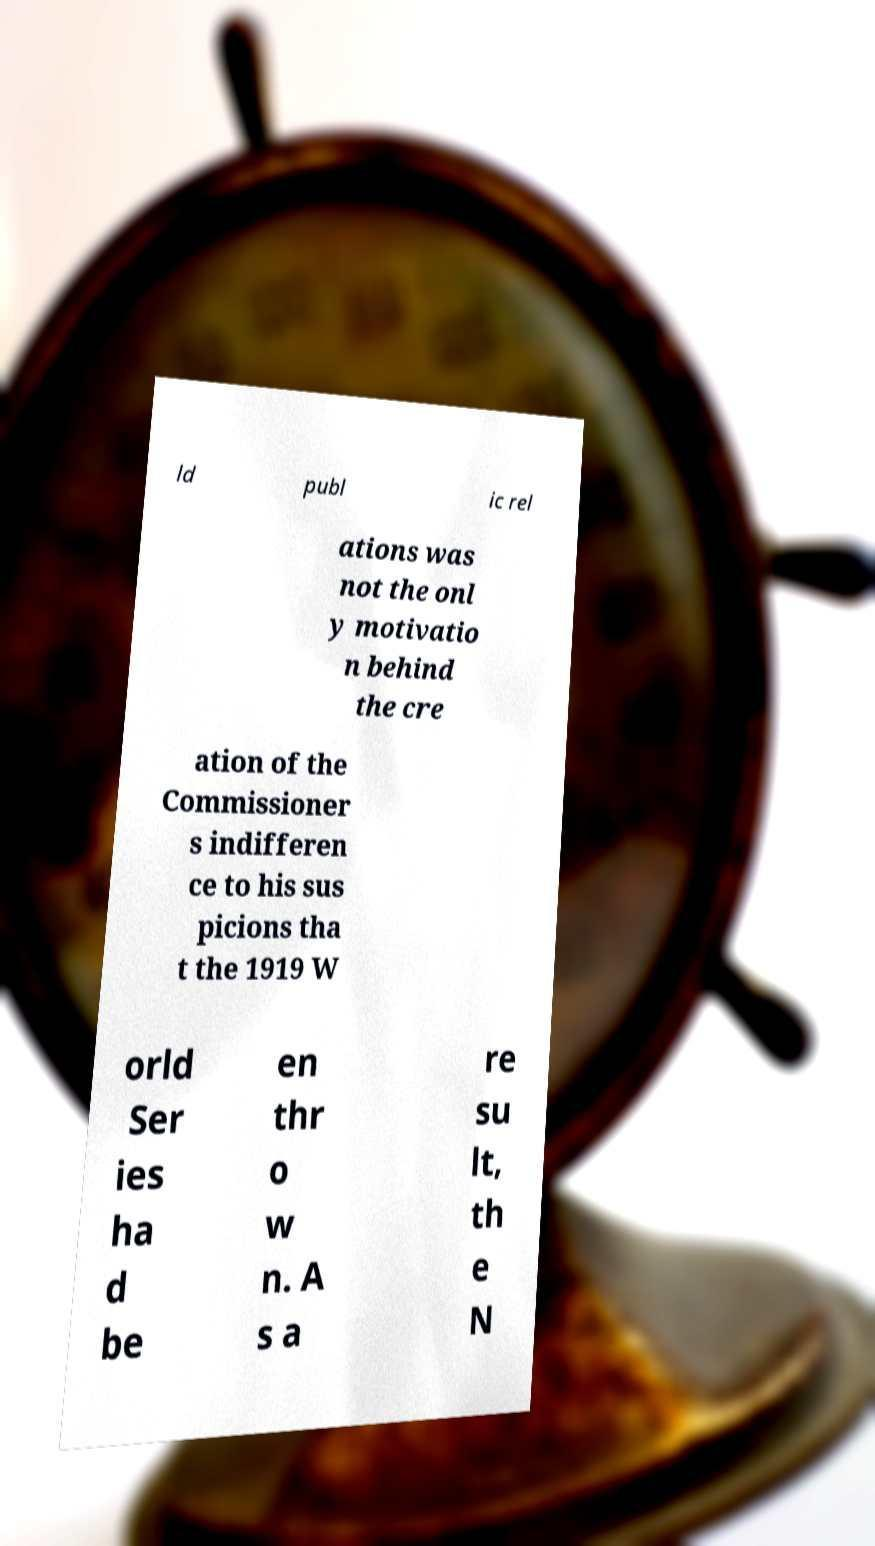Please read and relay the text visible in this image. What does it say? ld publ ic rel ations was not the onl y motivatio n behind the cre ation of the Commissioner s indifferen ce to his sus picions tha t the 1919 W orld Ser ies ha d be en thr o w n. A s a re su lt, th e N 